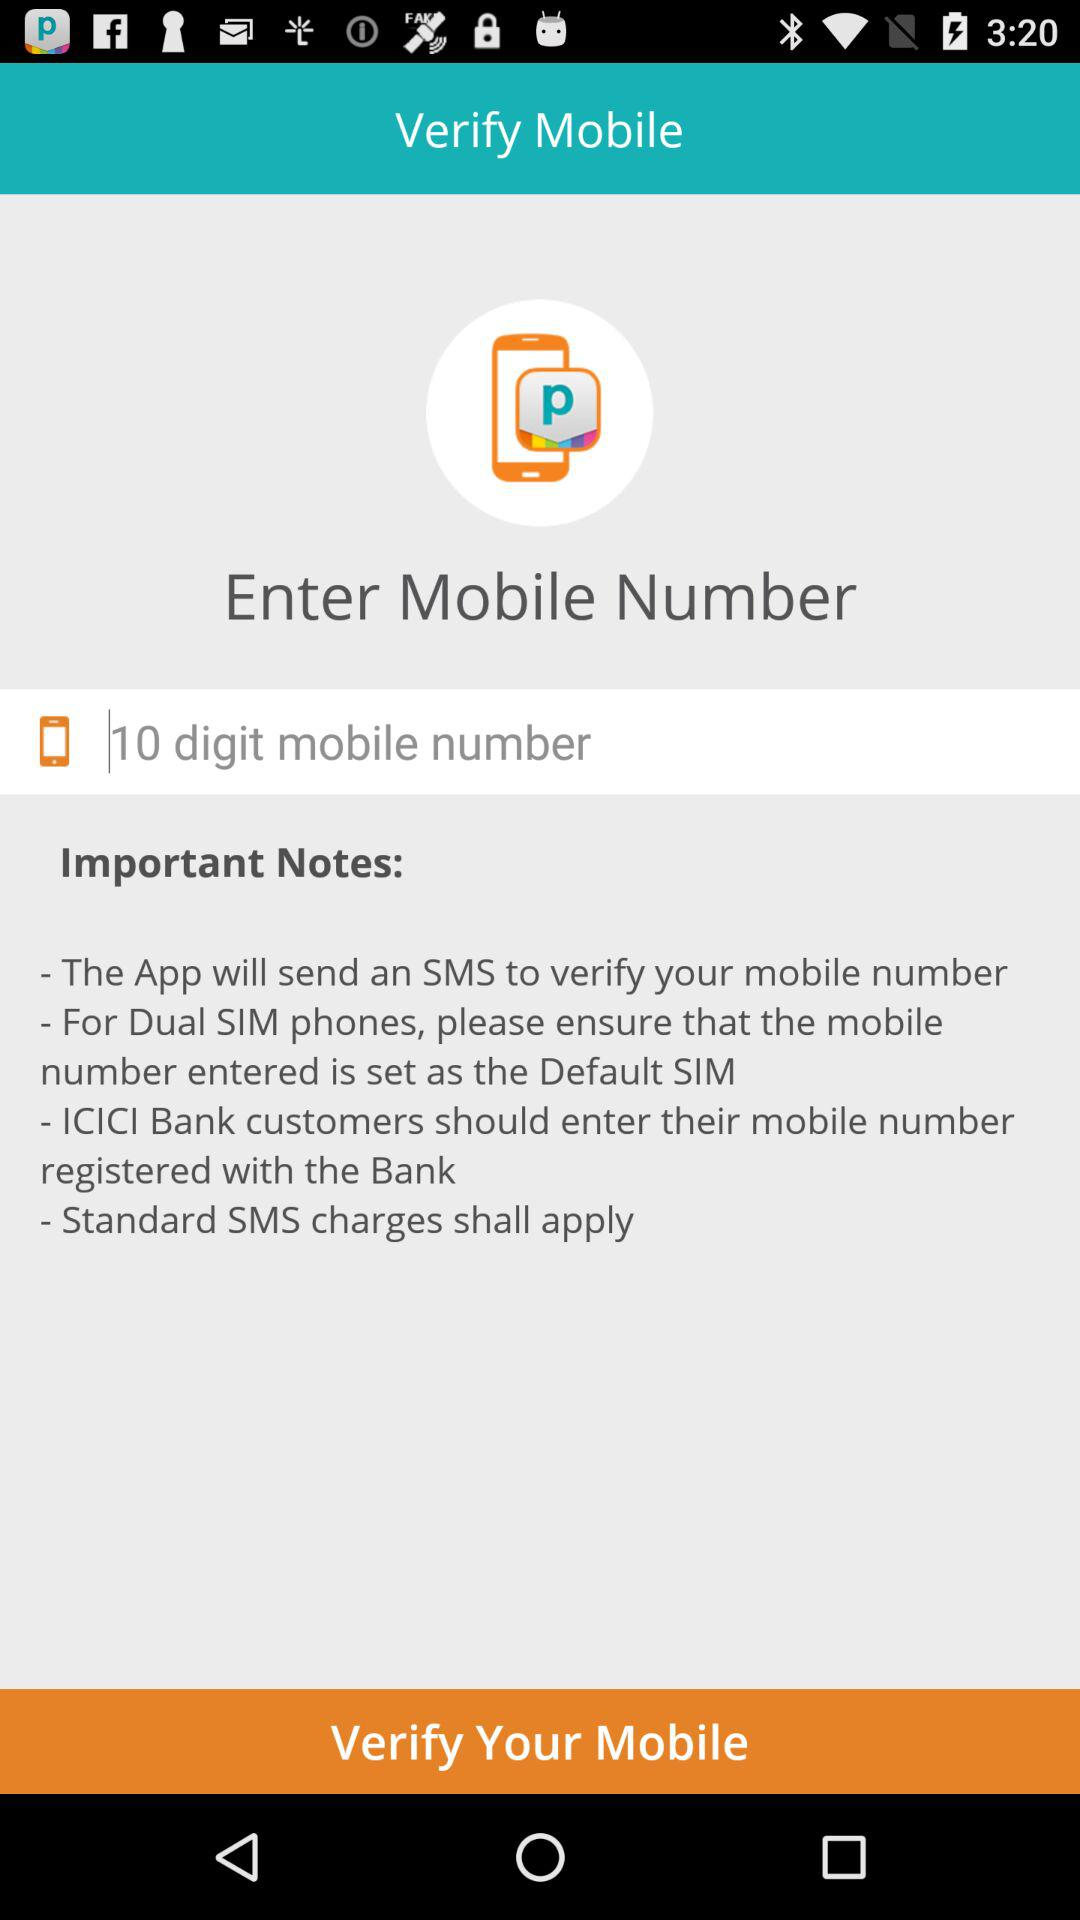How many important notes are there?
Answer the question using a single word or phrase. 4 